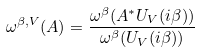Convert formula to latex. <formula><loc_0><loc_0><loc_500><loc_500>\omega ^ { \beta , V } ( A ) = \frac { \omega ^ { \beta } ( A ^ { * } U _ { V } ( i \beta ) ) } { \omega ^ { \beta } ( U _ { V } ( i \beta ) ) }</formula> 